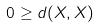Convert formula to latex. <formula><loc_0><loc_0><loc_500><loc_500>0 \geq d ( X , X )</formula> 